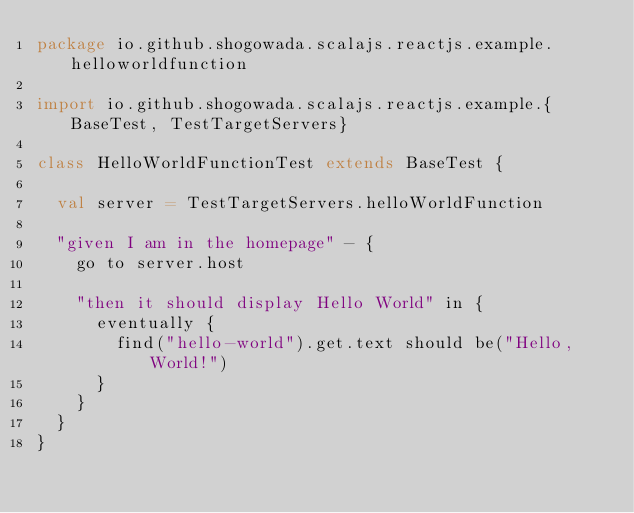<code> <loc_0><loc_0><loc_500><loc_500><_Scala_>package io.github.shogowada.scalajs.reactjs.example.helloworldfunction

import io.github.shogowada.scalajs.reactjs.example.{BaseTest, TestTargetServers}

class HelloWorldFunctionTest extends BaseTest {

  val server = TestTargetServers.helloWorldFunction

  "given I am in the homepage" - {
    go to server.host

    "then it should display Hello World" in {
      eventually {
        find("hello-world").get.text should be("Hello, World!")
      }
    }
  }
}
</code> 